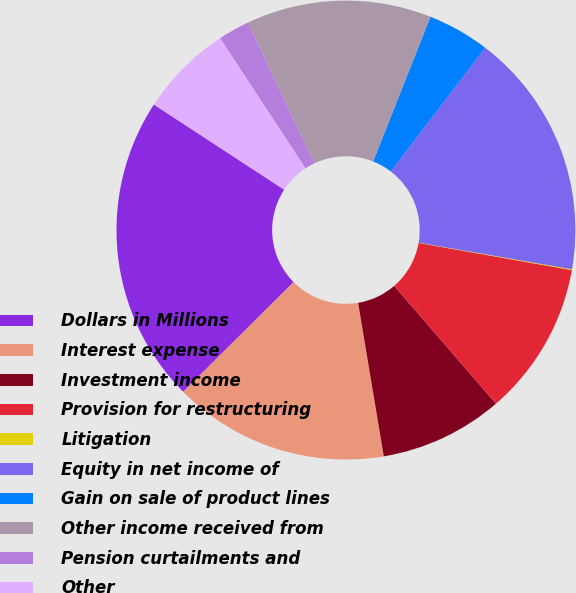Convert chart. <chart><loc_0><loc_0><loc_500><loc_500><pie_chart><fcel>Dollars in Millions<fcel>Interest expense<fcel>Investment income<fcel>Provision for restructuring<fcel>Litigation<fcel>Equity in net income of<fcel>Gain on sale of product lines<fcel>Other income received from<fcel>Pension curtailments and<fcel>Other<nl><fcel>21.66%<fcel>15.18%<fcel>8.7%<fcel>10.86%<fcel>0.06%<fcel>17.34%<fcel>4.38%<fcel>13.02%<fcel>2.22%<fcel>6.54%<nl></chart> 